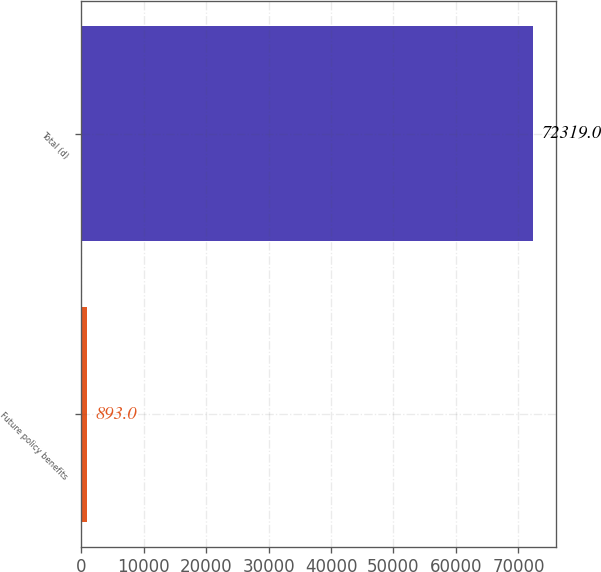Convert chart to OTSL. <chart><loc_0><loc_0><loc_500><loc_500><bar_chart><fcel>Future policy benefits<fcel>Total (d)<nl><fcel>893<fcel>72319<nl></chart> 